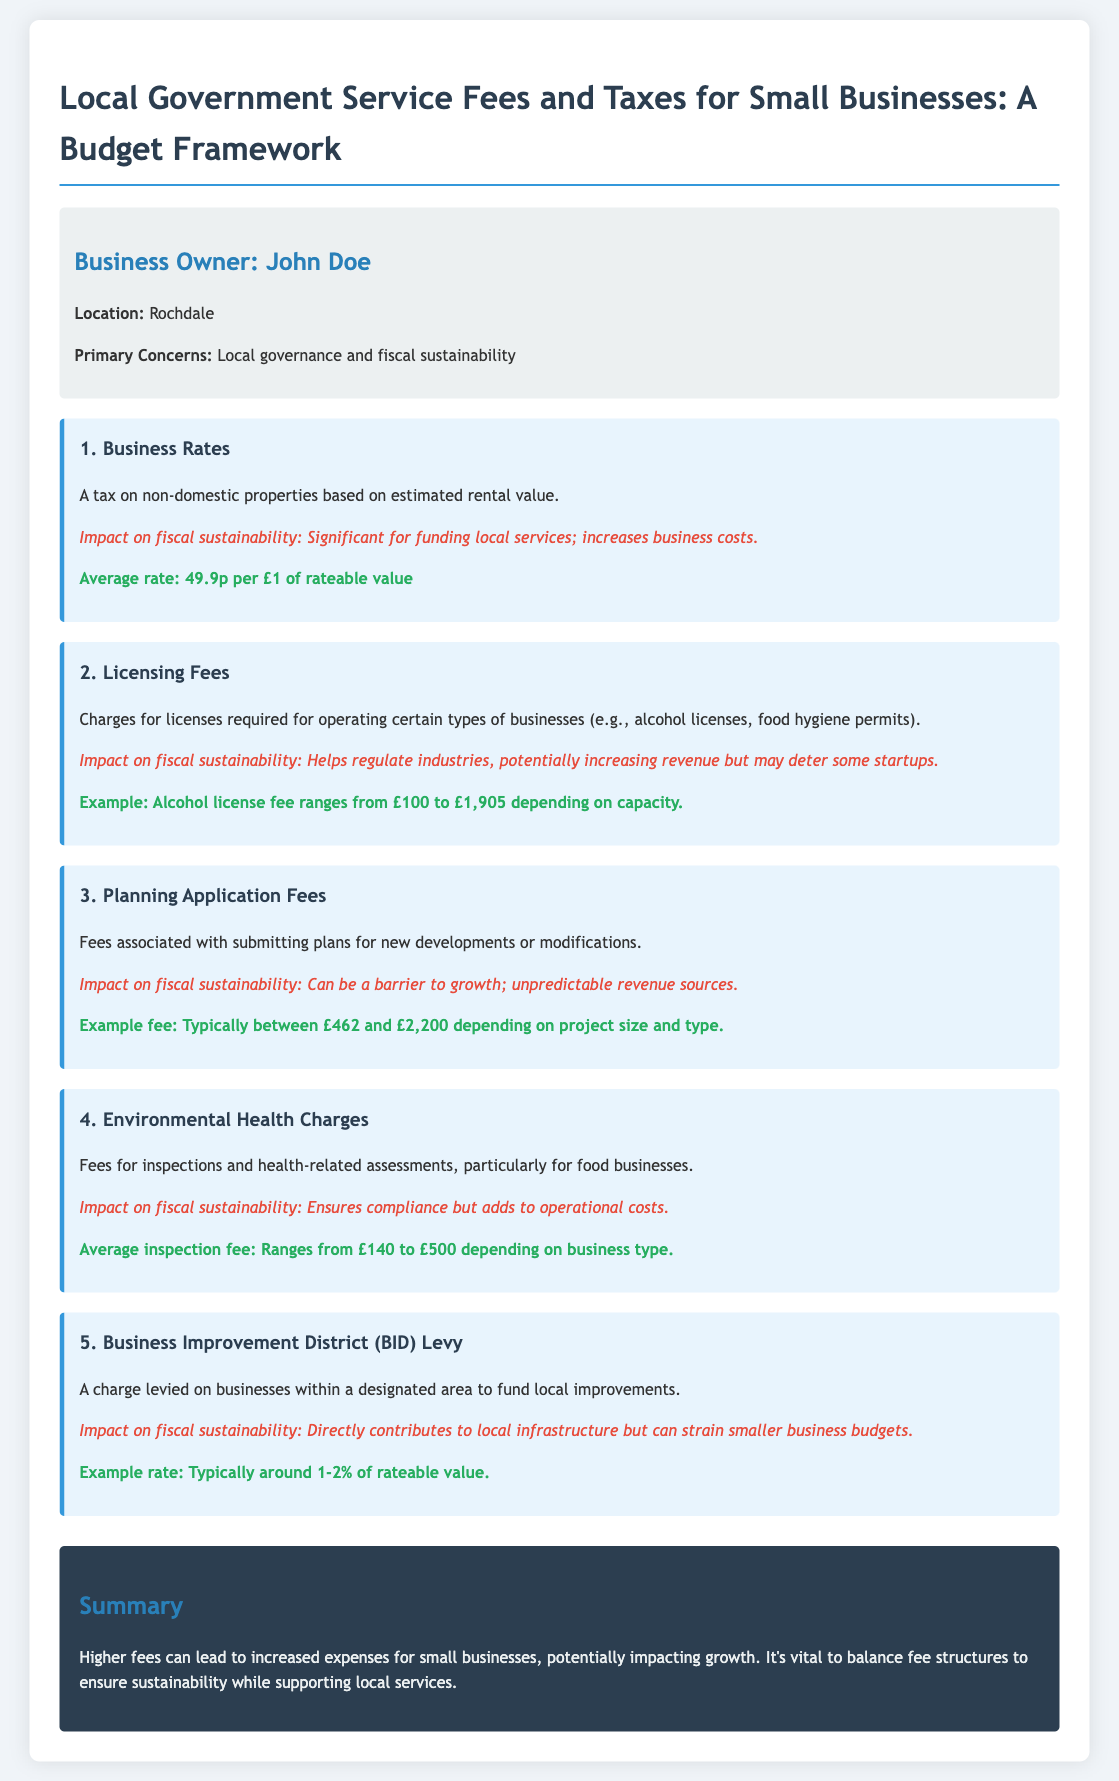What is the average rate for business rates? The average rate for business rates is given as 49.9p per £1 of rateable value.
Answer: 49.9p per £1 What is the range of the alcohol license fee? The document states that the alcohol license fee ranges from £100 to £1,905 depending on capacity.
Answer: £100 to £1,905 What is the example fee for planning applications? The document mentions that the typical example fee for planning applications is between £462 and £2,200 depending on project size and type.
Answer: £462 to £2,200 What is the impact of business rates on fiscal sustainability? The impact on fiscal sustainability is described as significant for funding local services and increases business costs.
Answer: Significant for funding local services; increases business costs What percentage of rateable value does the BID Levy typically charge? The BID Levy is typically around 1-2% of rateable value.
Answer: 1-2% What is one concern regarding the environmental health charges? The environmental health charges ensure compliance but add to operational costs.
Answer: Adds to operational costs 